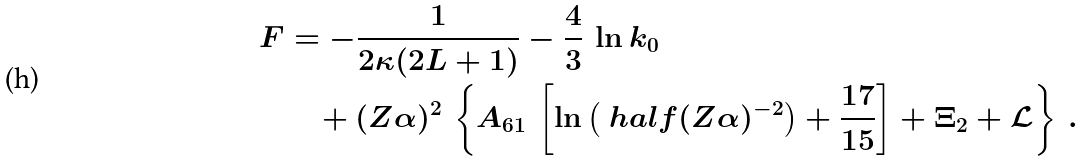<formula> <loc_0><loc_0><loc_500><loc_500>F & = - \frac { 1 } { 2 \kappa ( 2 L + 1 ) } - \frac { 4 } { 3 } \, \ln k _ { 0 } \\ & \quad + ( Z \alpha ) ^ { 2 } \, \left \{ A _ { 6 1 } \, \left [ \ln \left ( \ h a l f ( Z \alpha ) ^ { - 2 } \right ) + \frac { 1 7 } { 1 5 } \right ] + \Xi _ { 2 } + { \mathcal { L } } \right \} \, .</formula> 